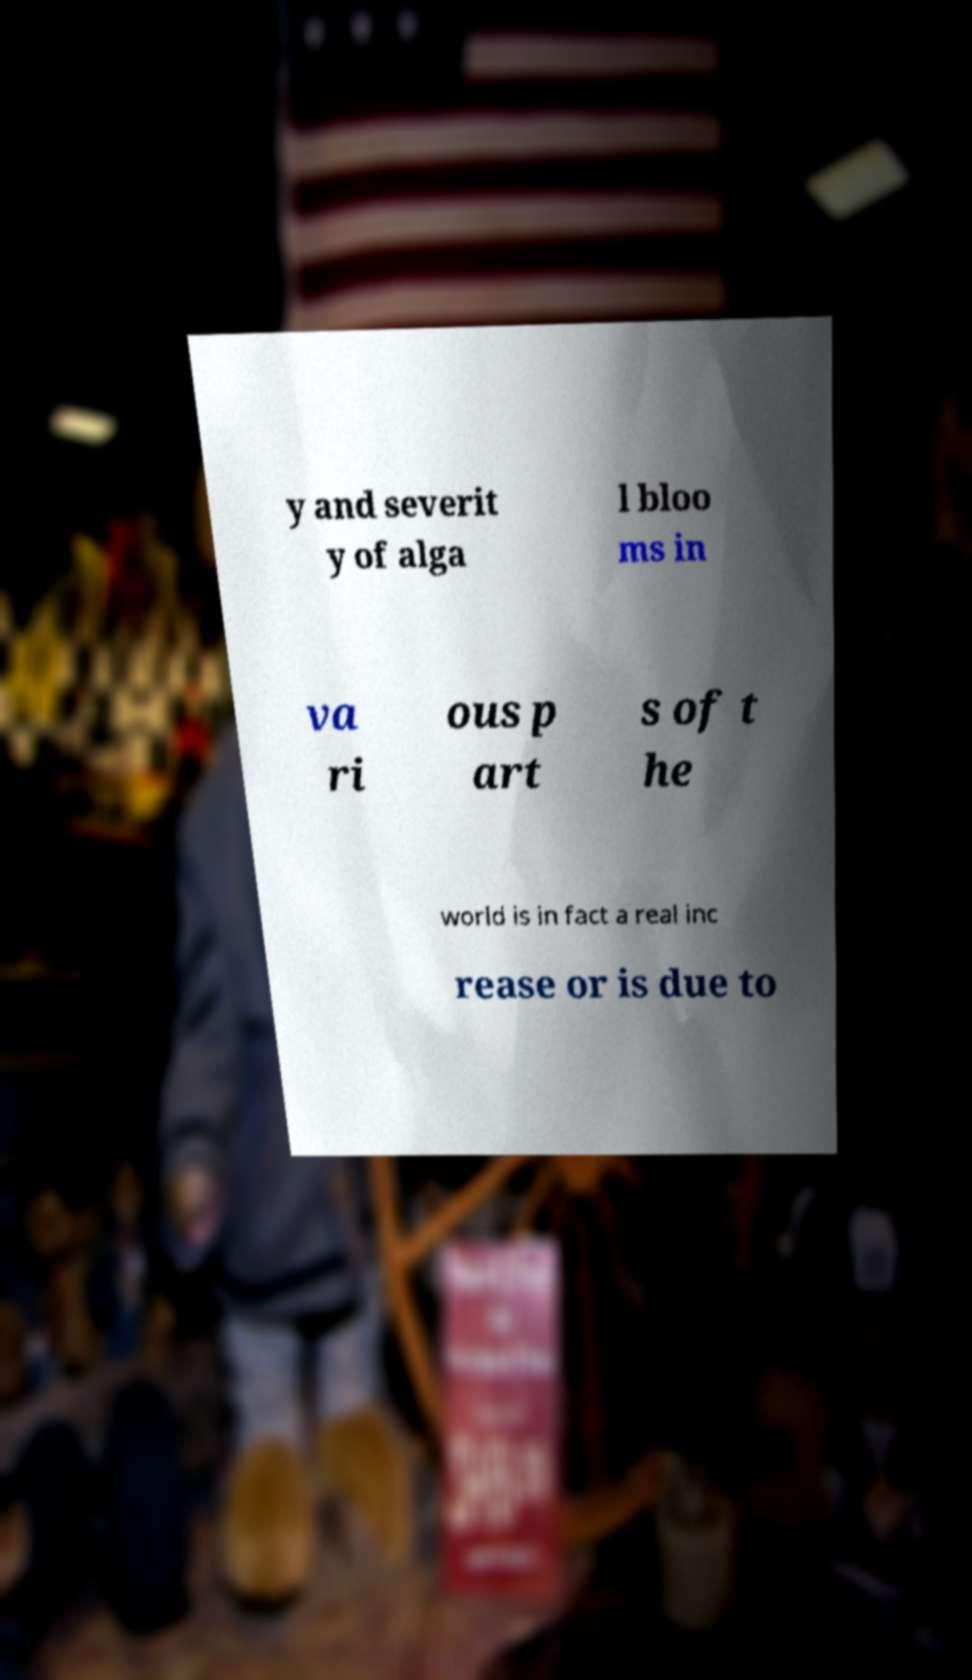There's text embedded in this image that I need extracted. Can you transcribe it verbatim? y and severit y of alga l bloo ms in va ri ous p art s of t he world is in fact a real inc rease or is due to 